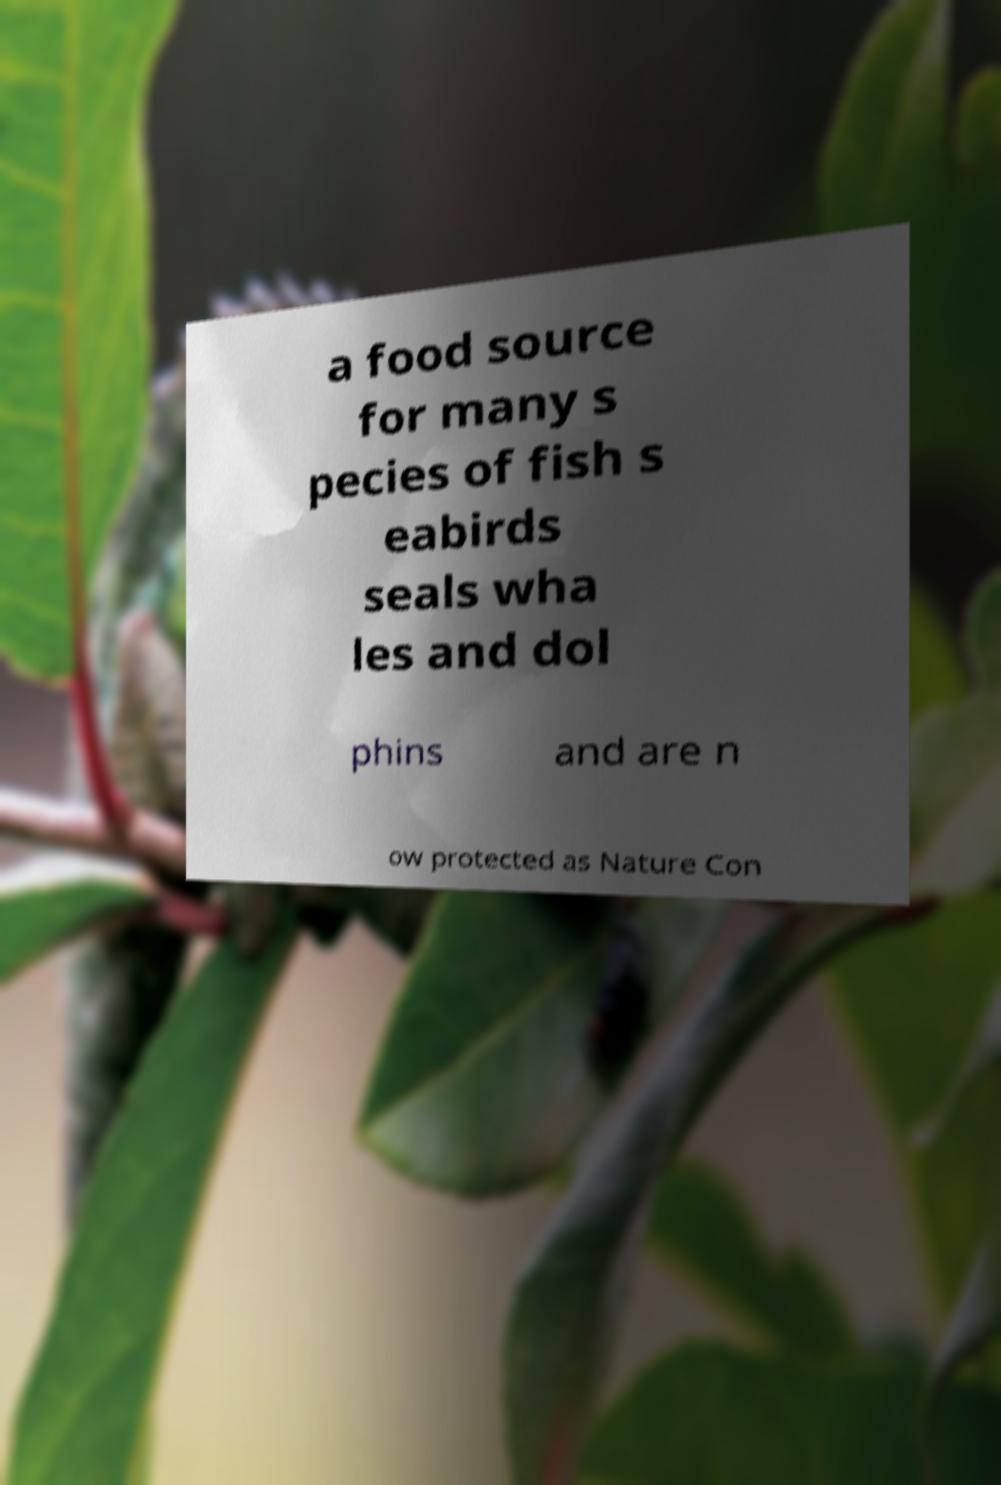Could you assist in decoding the text presented in this image and type it out clearly? a food source for many s pecies of fish s eabirds seals wha les and dol phins and are n ow protected as Nature Con 